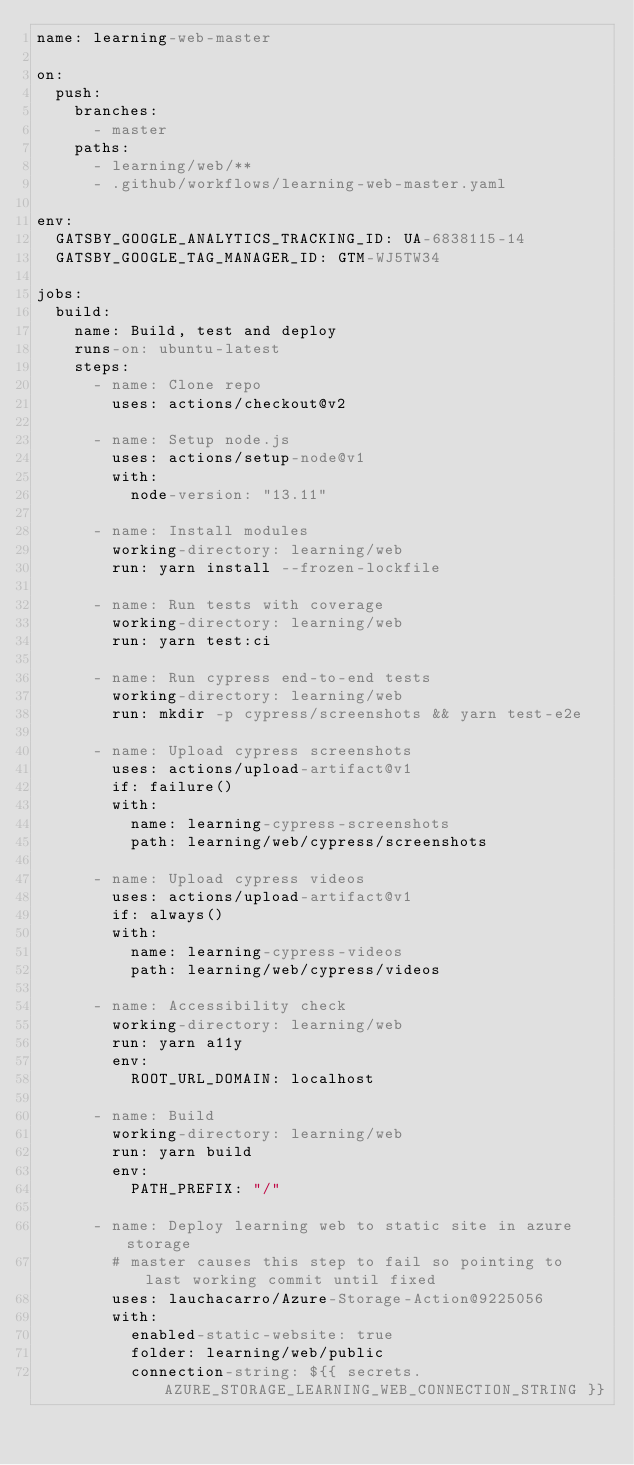<code> <loc_0><loc_0><loc_500><loc_500><_YAML_>name: learning-web-master

on:
  push:
    branches:
      - master
    paths:
      - learning/web/**
      - .github/workflows/learning-web-master.yaml

env:
  GATSBY_GOOGLE_ANALYTICS_TRACKING_ID: UA-6838115-14
  GATSBY_GOOGLE_TAG_MANAGER_ID: GTM-WJ5TW34

jobs:
  build:
    name: Build, test and deploy
    runs-on: ubuntu-latest
    steps:
      - name: Clone repo
        uses: actions/checkout@v2

      - name: Setup node.js
        uses: actions/setup-node@v1
        with:
          node-version: "13.11"

      - name: Install modules
        working-directory: learning/web
        run: yarn install --frozen-lockfile

      - name: Run tests with coverage
        working-directory: learning/web
        run: yarn test:ci

      - name: Run cypress end-to-end tests
        working-directory: learning/web
        run: mkdir -p cypress/screenshots && yarn test-e2e

      - name: Upload cypress screenshots
        uses: actions/upload-artifact@v1
        if: failure()
        with:
          name: learning-cypress-screenshots
          path: learning/web/cypress/screenshots

      - name: Upload cypress videos
        uses: actions/upload-artifact@v1
        if: always()
        with:
          name: learning-cypress-videos
          path: learning/web/cypress/videos

      - name: Accessibility check
        working-directory: learning/web
        run: yarn a11y
        env:
          ROOT_URL_DOMAIN: localhost

      - name: Build
        working-directory: learning/web
        run: yarn build
        env:
          PATH_PREFIX: "/"

      - name: Deploy learning web to static site in azure storage
        # master causes this step to fail so pointing to last working commit until fixed
        uses: lauchacarro/Azure-Storage-Action@9225056
        with:
          enabled-static-website: true
          folder: learning/web/public
          connection-string: ${{ secrets.AZURE_STORAGE_LEARNING_WEB_CONNECTION_STRING }}
</code> 